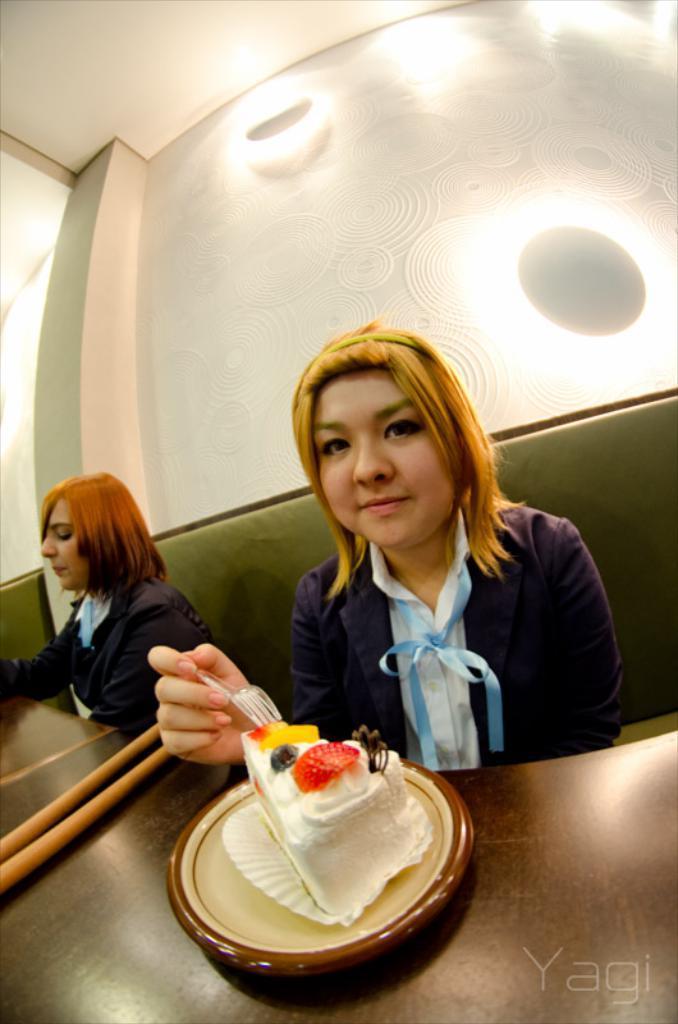Please provide a concise description of this image. In the image two women are sitting and eating. Behind them there is a wall and lights. Top left side of the there is a roof. Bottom of the image there is a table on the there is a plate and cake and there are chopsticks. 